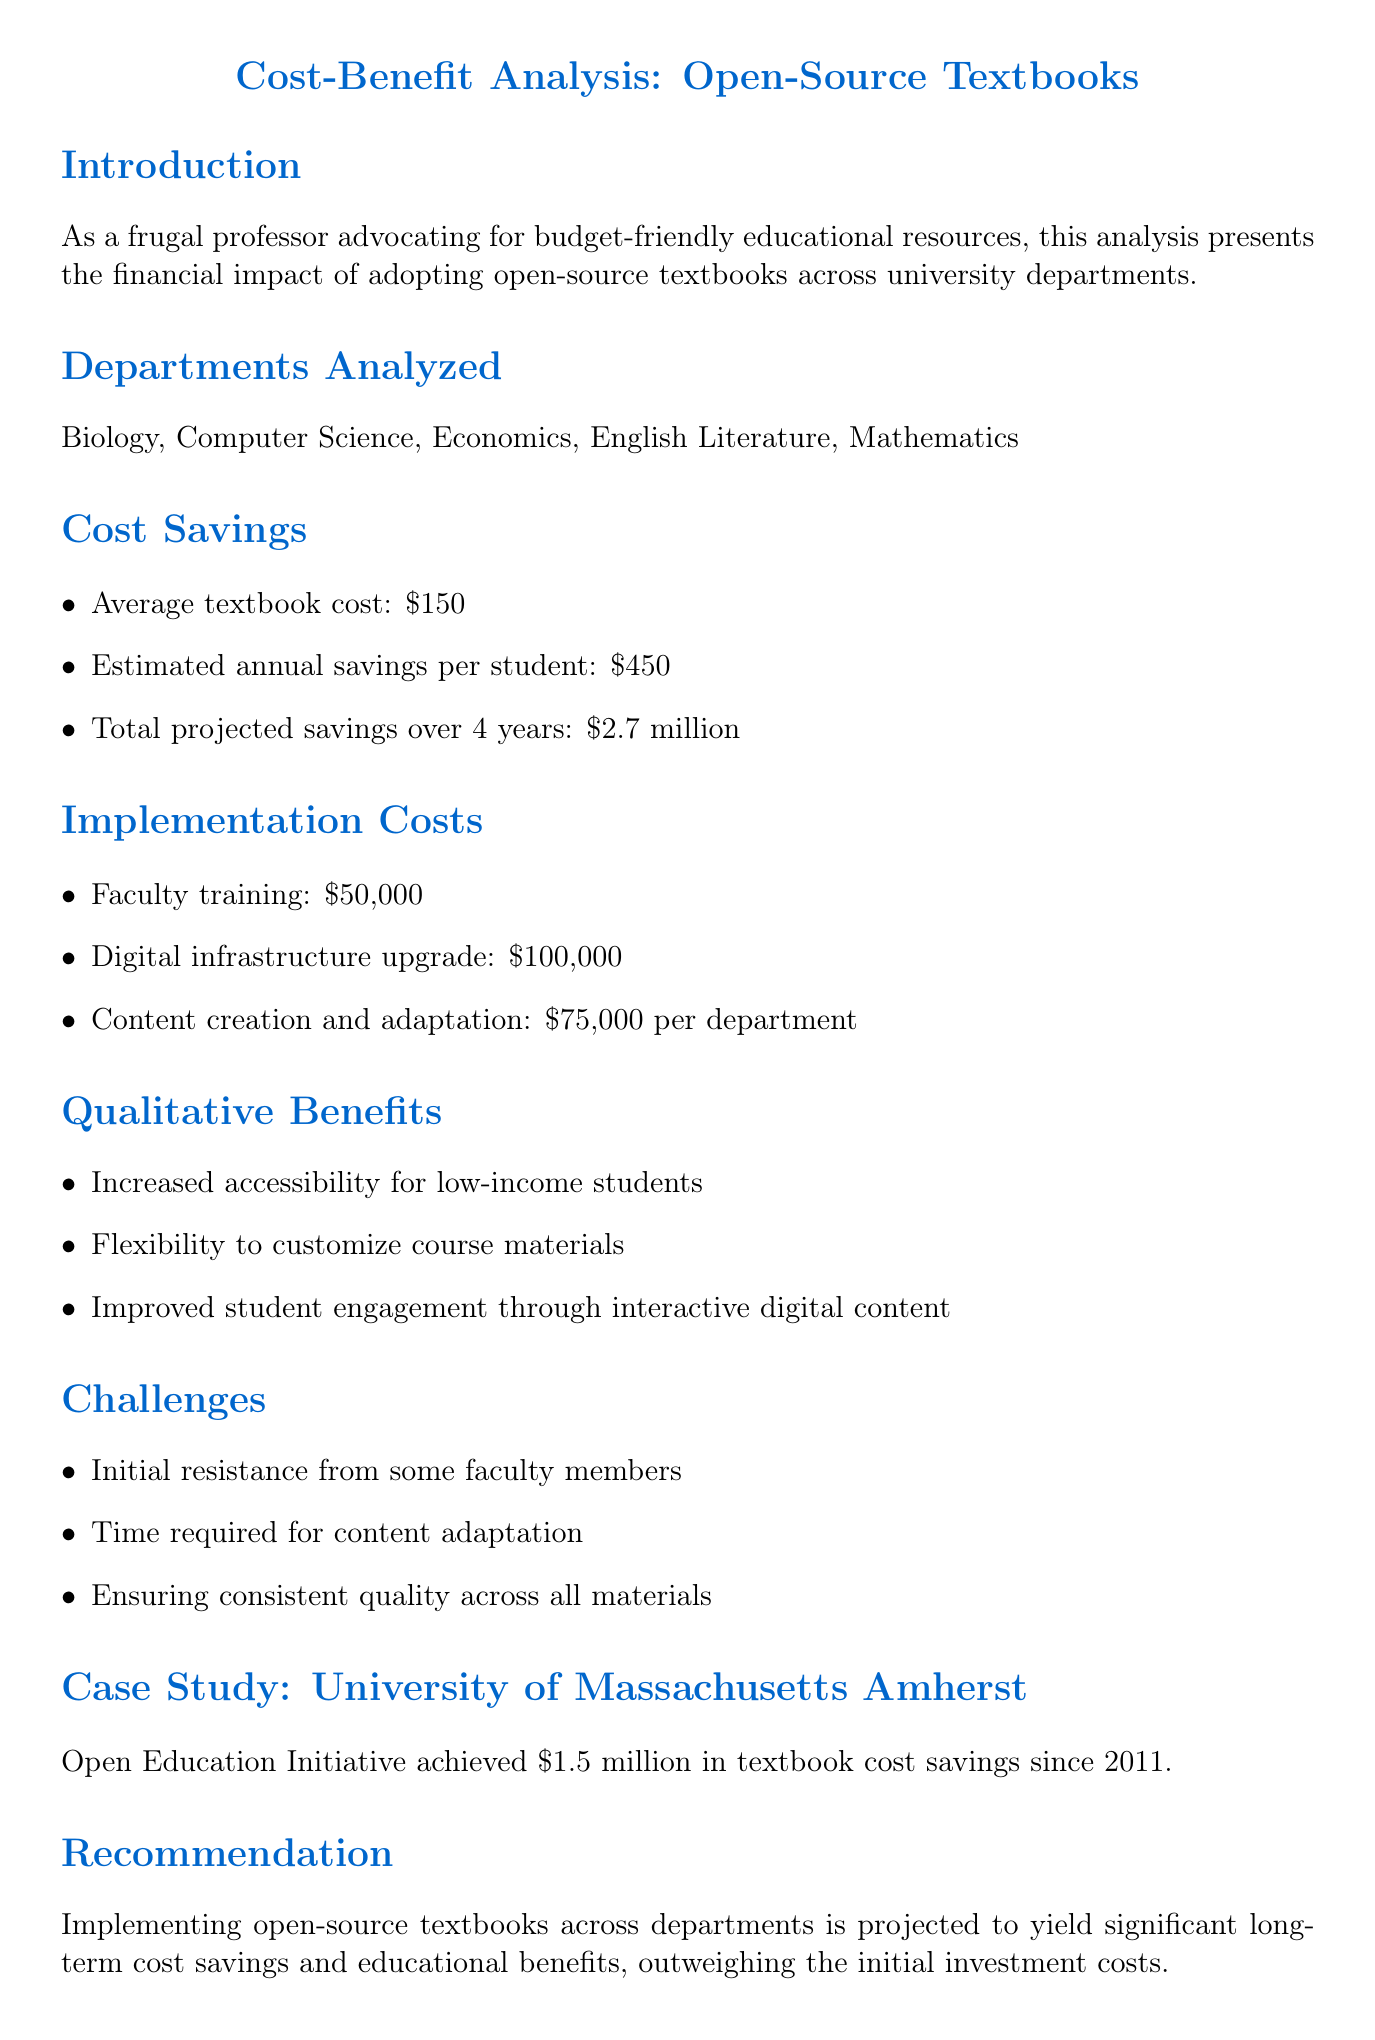What is the average textbook cost? The average textbook cost is mentioned in the cost savings section of the document, specifically listed as $150.
Answer: $150 What is the total projected savings over 4 years? The total projected savings over 4 years is highlighted in the cost savings section, and it equals $2.7 million.
Answer: $2.7 million Which department's implementation cost includes $75,000? The implementation cost for content creation and adaptation specifies $75,000 per department, indicating that all departments analyzed will incur this cost.
Answer: All departments What qualitative benefit relates to low-income students? One of the qualitative benefits mentioned in the document is "Increased accessibility for low-income students."
Answer: Increased accessibility for low-income students How much savings did the University of Massachusetts Amherst achieve? The case study section reports that the University of Massachusetts Amherst achieved $1.5 million in textbook cost savings since 2011.
Answer: $1.5 million What is one challenge faced in implementing open-source textbooks? The document lists multiple challenges, one of which is "Initial resistance from some faculty members."
Answer: Initial resistance from some faculty members What is the recommendation based on the analysis? The recommendation states that implementing open-source textbooks is projected to yield significant long-term cost savings and educational benefits.
Answer: Projected to yield significant long-term cost savings and educational benefits What was the estimated annual savings per student? The estimated annual savings per student is provided in the cost savings section and is listed as $450.
Answer: $450 